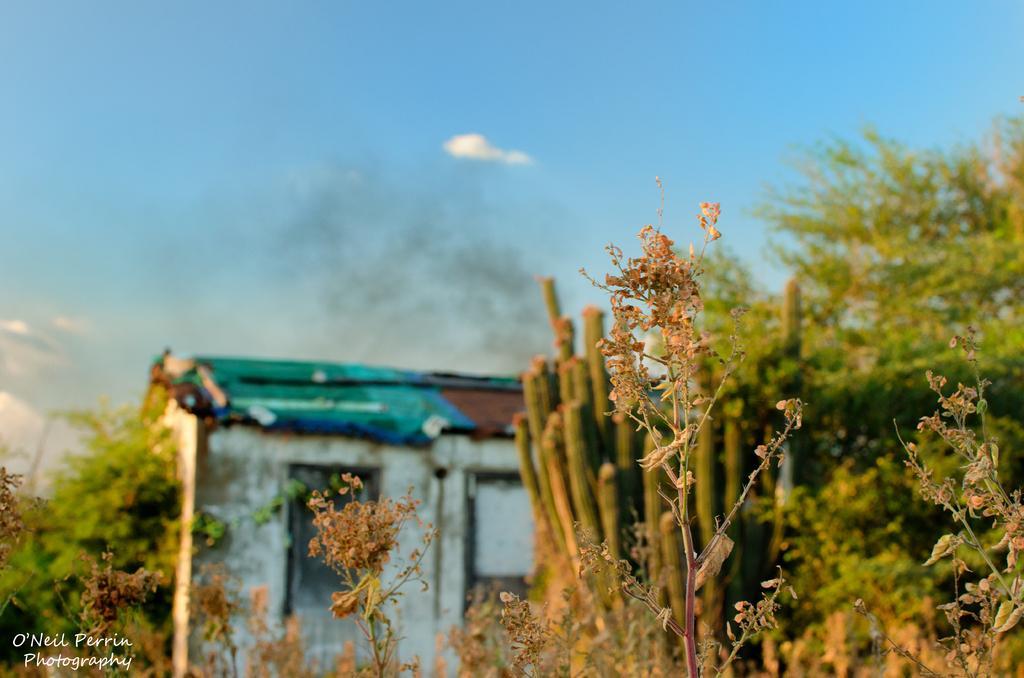Please provide a concise description of this image. In this image, I can see plants and trees. This looks like a house. This is the watermark on the image. These are the clouds in the sky. 